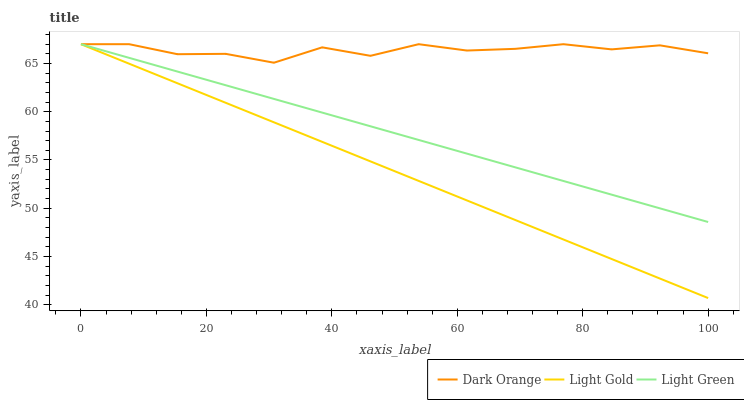Does Light Green have the minimum area under the curve?
Answer yes or no. No. Does Light Green have the maximum area under the curve?
Answer yes or no. No. Is Light Green the smoothest?
Answer yes or no. No. Is Light Green the roughest?
Answer yes or no. No. Does Light Green have the lowest value?
Answer yes or no. No. 